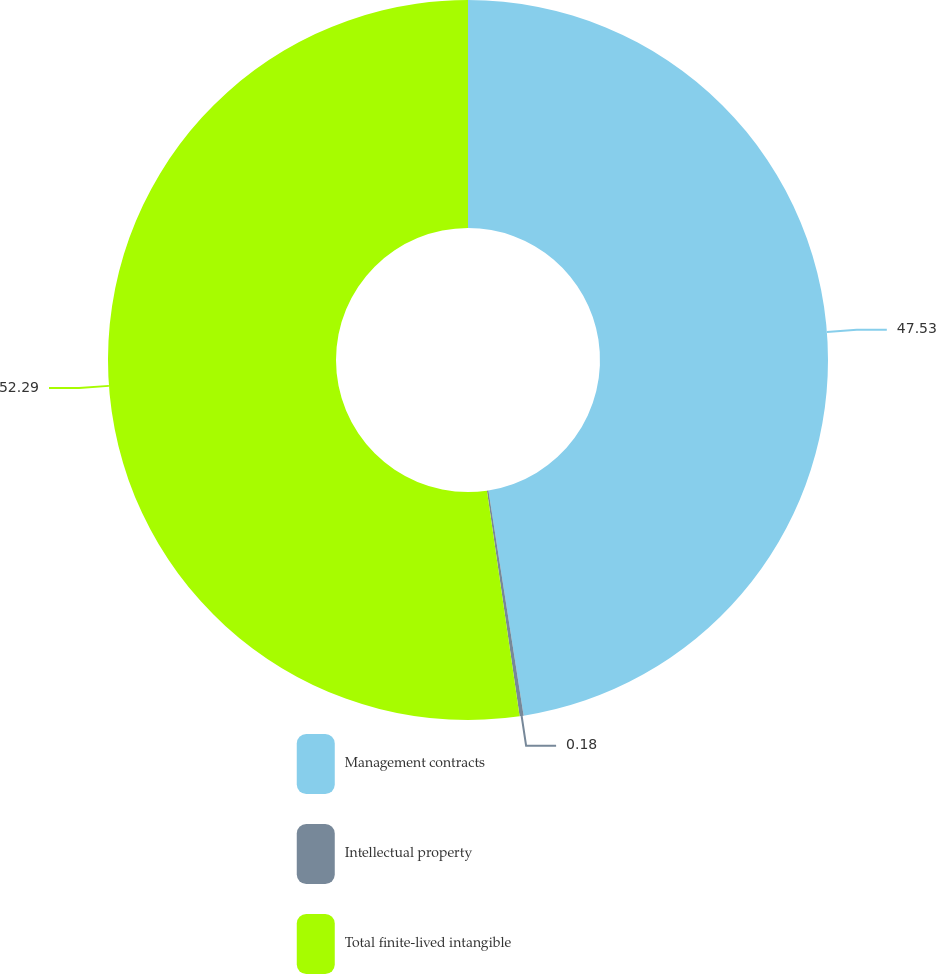<chart> <loc_0><loc_0><loc_500><loc_500><pie_chart><fcel>Management contracts<fcel>Intellectual property<fcel>Total finite-lived intangible<nl><fcel>47.53%<fcel>0.18%<fcel>52.29%<nl></chart> 